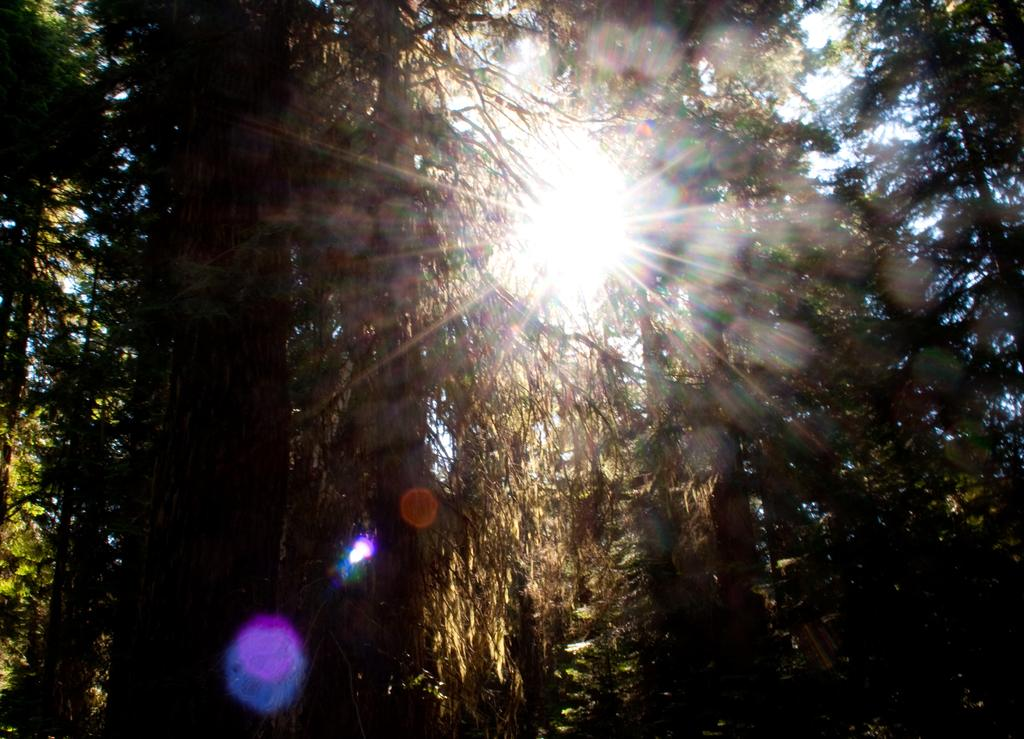What type of vegetation can be seen in the image? There are trees and plants in the image. What is visible at the top of the image? The sky is visible at the top of the image. Can the sun be seen in the image? Yes, the sun is observable in the sky. How many sisters are playing the drum in the image? There are no sisters or drums present in the image. 